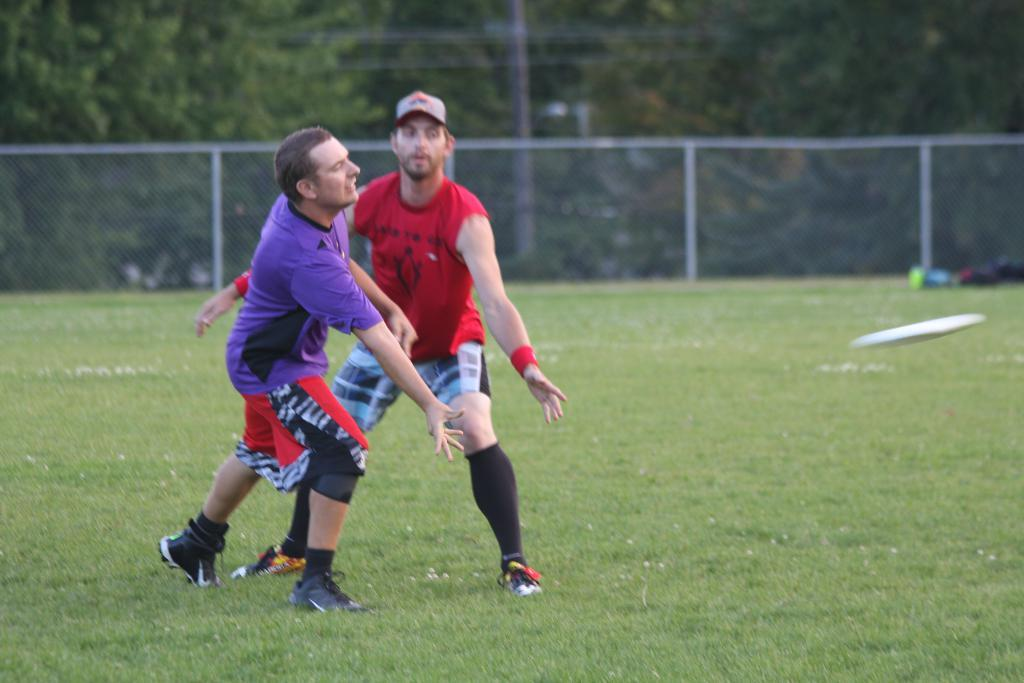How many people are in the image? There are 2 people in the image. What are the people doing in the image? The people are playing on the grass. What object can be seen on the right side of the image? There is a white frisbee on the right side of the image. What structures are present in the image? There is a fence and a pole in the image. What type of vegetation is visible in the image? There are trees visible in the image. Reasoning: Let's think step by step by following the given guidelines. We start by identifying the main subjects in the image, which are the two people. Then, we describe their actions and the objects they are interacting with, such as the frisbee. Next, we mention the structures present in the image, which are the fence and pole. Finally, we identify the type of vegetation visible, which are the trees. Absurd Question/Answer: What type of bean is being sorted by the people in the image? There is no bean or sorting activity present in the image; the people are playing on the grass with a frisbee. 